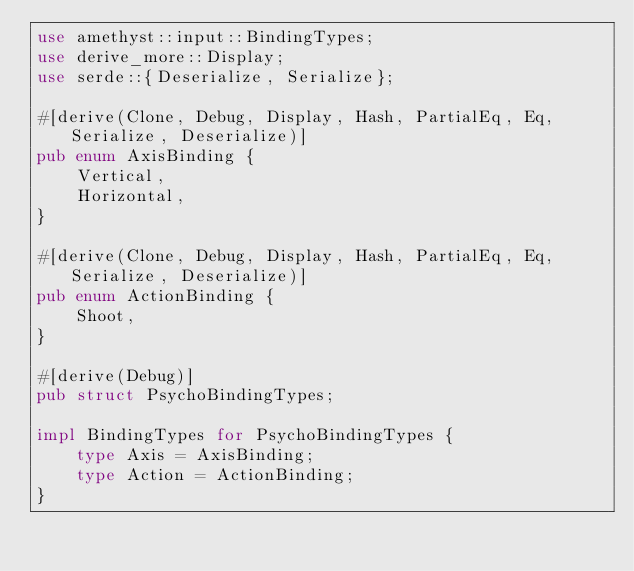<code> <loc_0><loc_0><loc_500><loc_500><_Rust_>use amethyst::input::BindingTypes;
use derive_more::Display;
use serde::{Deserialize, Serialize};

#[derive(Clone, Debug, Display, Hash, PartialEq, Eq, Serialize, Deserialize)]
pub enum AxisBinding {
    Vertical,
    Horizontal,
}

#[derive(Clone, Debug, Display, Hash, PartialEq, Eq, Serialize, Deserialize)]
pub enum ActionBinding {
    Shoot,
}

#[derive(Debug)]
pub struct PsychoBindingTypes;

impl BindingTypes for PsychoBindingTypes {
    type Axis = AxisBinding;
    type Action = ActionBinding;
}
</code> 